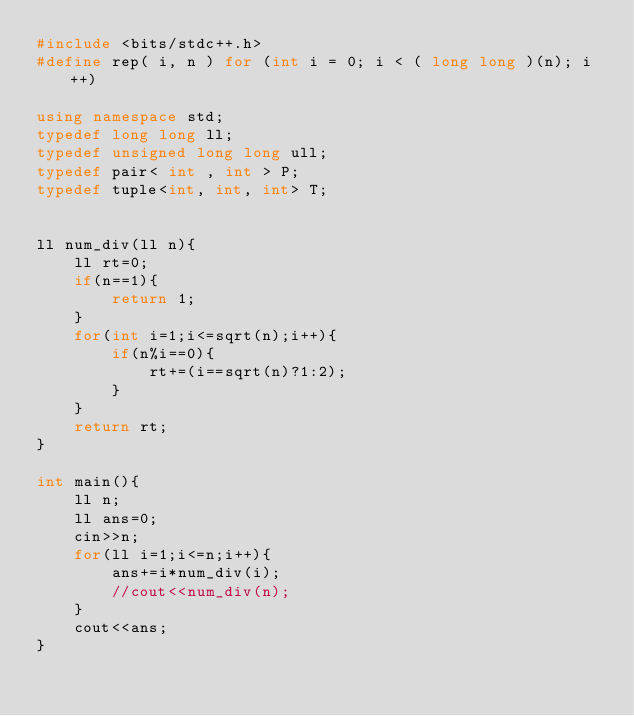<code> <loc_0><loc_0><loc_500><loc_500><_C++_>#include <bits/stdc++.h>
#define rep( i, n ) for (int i = 0; i < ( long long )(n); i++)

using namespace std;
typedef long long ll;
typedef unsigned long long ull;
typedef pair< int , int > P;
typedef tuple<int, int, int> T;
    

ll num_div(ll n){
    ll rt=0;
    if(n==1){
        return 1;
    }
    for(int i=1;i<=sqrt(n);i++){
        if(n%i==0){
            rt+=(i==sqrt(n)?1:2);
        }
    }
    return rt;
}

int main(){
    ll n;
    ll ans=0;
    cin>>n;
    for(ll i=1;i<=n;i++){
        ans+=i*num_div(i);
        //cout<<num_div(n);
    }
    cout<<ans;
}

</code> 